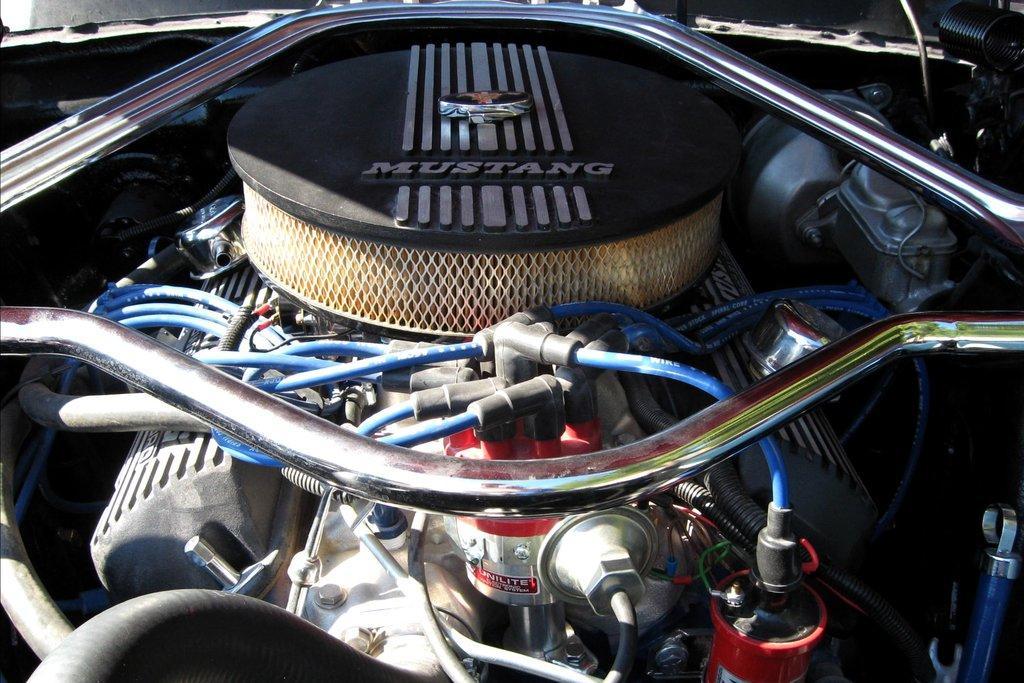Describe this image in one or two sentences. In this image I can see the engine of the car. And there are few blue colored pipes can be seen. I can also see two metal rods inside the engine. 